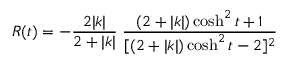<formula> <loc_0><loc_0><loc_500><loc_500>R ( t ) = - \frac { 2 | k | } { 2 + | k | } \, \frac { ( 2 + | k | ) \cosh ^ { 2 } t + 1 } { [ ( 2 + | k | ) \cosh ^ { 2 } t - 2 ] ^ { 2 } }</formula> 